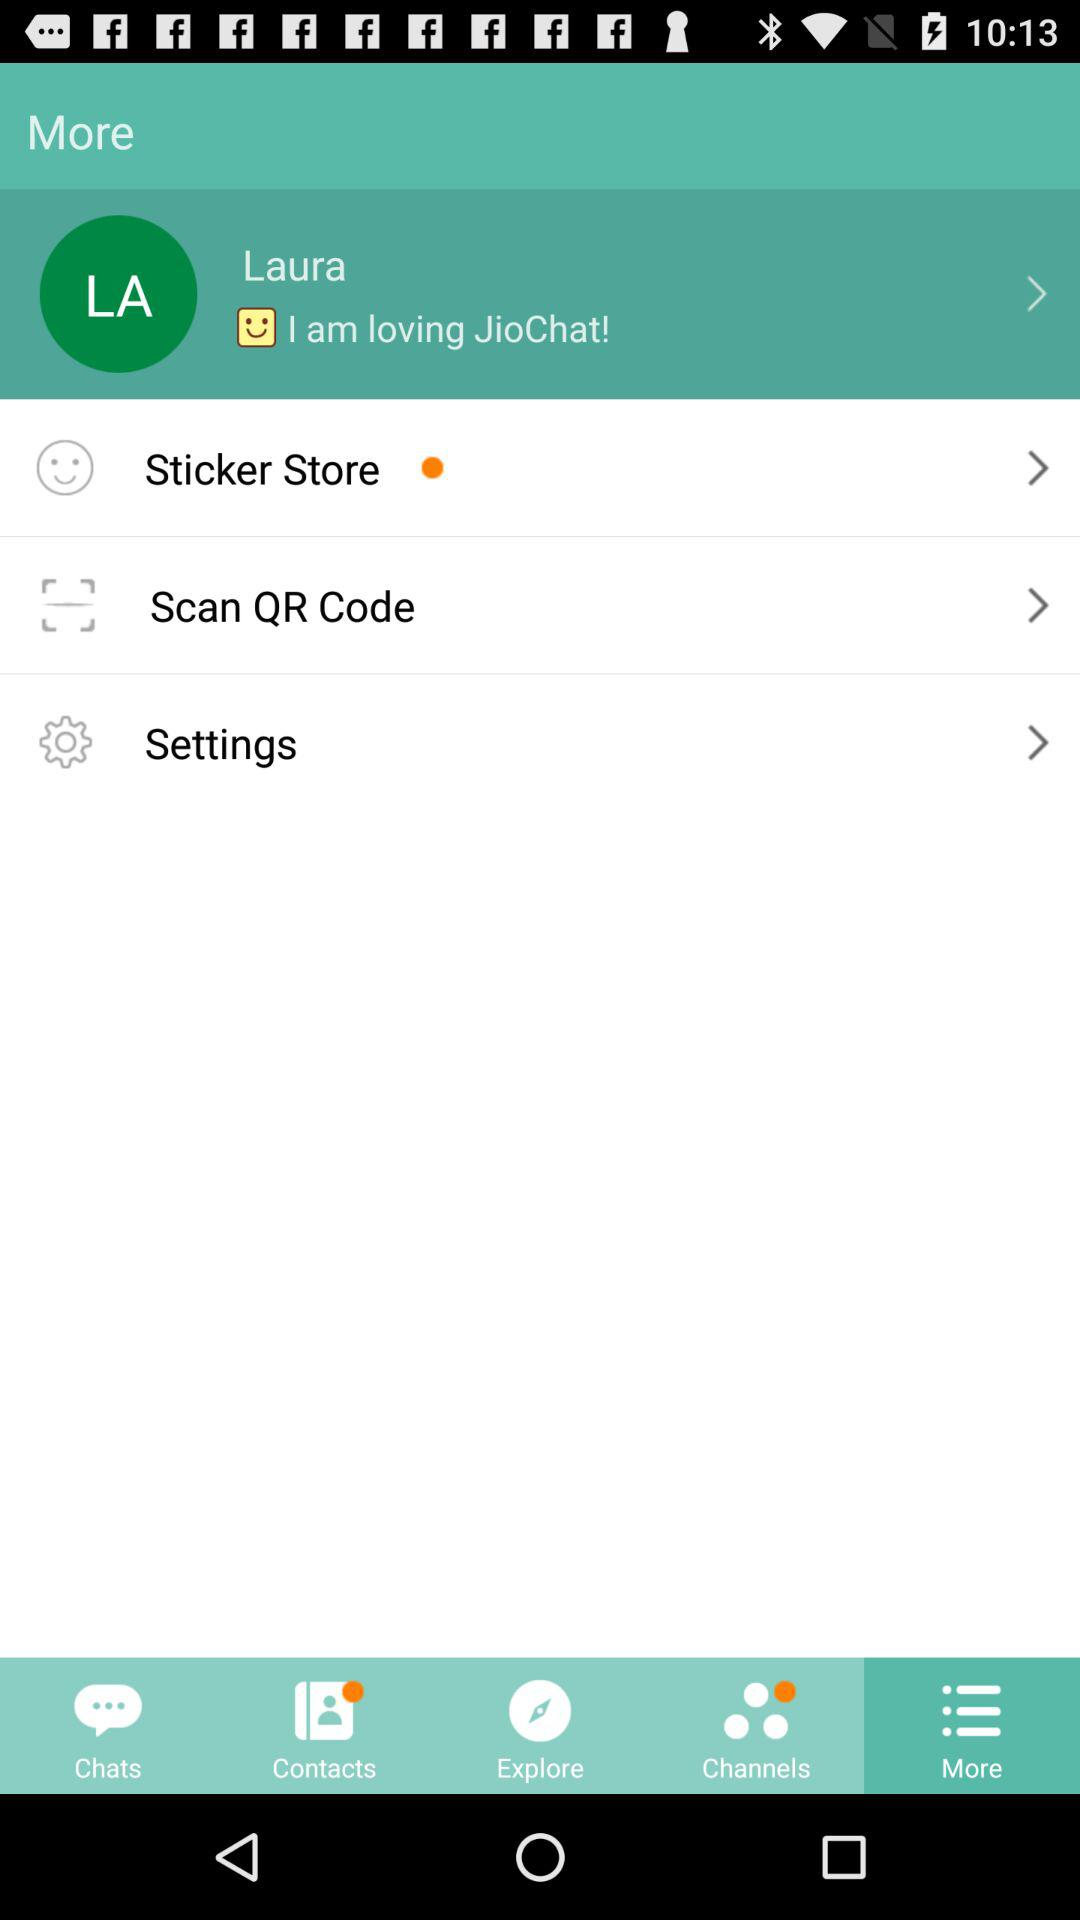What is the profile name? The profile name is Laura. 